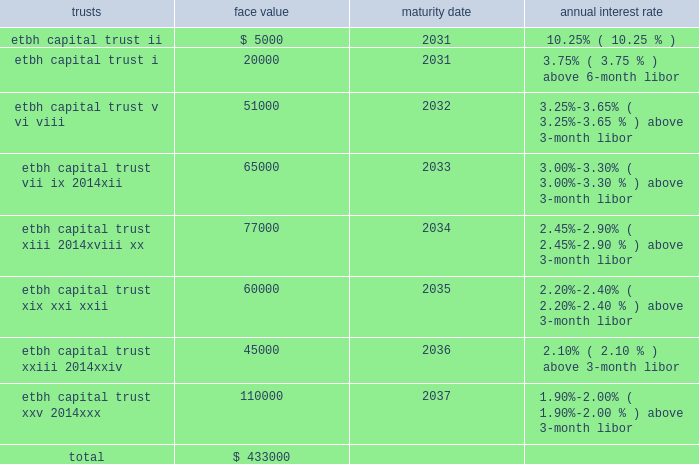Fhlb advances and other borrowings fhlb advances 2014the company had $ 0.7 billion and $ 0.5 billion in floating-rate and $ 0.2 billion and $ 1.8 billion in fixed-rate fhlb advances at december 31 , 2012 and 2011 , respectively .
The floating-rate advances adjust quarterly based on the libor .
During the year ended december 31 , 2012 , $ 650.0 million of fixed-rate fhlb advances were converted to floating-rate for a total cost of approximately $ 128 million which was capitalized and will be amortized over the remaining maturities using the effective interest method .
In addition , during the year ended december 31 , 2012 , the company paid down in advance of maturity $ 1.0 billion of its fhlb advances and recorded $ 69.1 million in losses on the early extinguishment .
This loss was recorded in the gains ( losses ) on early extinguishment of debt line item in the consolidated statement of income ( loss ) .
The company did not have any similar transactions for the years ended december 31 , 2011 and 2010 .
As a condition of its membership in the fhlb atlanta , the company is required to maintain a fhlb stock investment currently equal to the lesser of : a percentage of 0.2% ( 0.2 % ) of total bank assets ; or a dollar cap amount of $ 26 million .
Additionally , the bank must maintain an activity based stock investment which is currently equal to 4.5% ( 4.5 % ) of the bank 2019s outstanding advances at the time of borrowing .
On a quarterly basis , the fhlb atlanta evaluates excess activity based stock holdings for its members and makes a determination regarding quarterly redemption of any excess activity based stock positions .
The company had an investment in fhlb stock of $ 67.4 million and $ 140.2 million at december 31 , 2012 and 2011 , respectively .
The company must also maintain qualified collateral as a percent of its advances , which varies based on the collateral type , and is further adjusted by the outcome of the most recent annual collateral audit and by fhlb 2019s internal ranking of the bank 2019s creditworthiness .
These advances are secured by a pool of mortgage loans and mortgage-backed securities .
At december 31 , 2012 and 2011 , the company pledged loans with a lendable value of $ 4.8 billion and $ 5.0 billion , respectively , of the one- to four-family and home equity loans as collateral in support of both its advances and unused borrowing lines .
Other borrowings 2014prior to 2008 , etbh raised capital through the formation of trusts , which sold trust preferred securities in the capital markets .
The capital securities must be redeemed in whole at the due date , which is generally 30 years after issuance .
Each trust issued floating rate cumulative preferred securities ( 201ctrust preferred securities 201d ) , at par with a liquidation amount of $ 1000 per capital security .
The trusts used the proceeds from the sale of issuances to purchase floating rate junior subordinated debentures ( 201csubordinated debentures 201d ) issued by etbh , which guarantees the trust obligations and contributed proceeds from the sale of its subordinated debentures to e*trade bank in the form of a capital contribution .
The most recent issuance of trust preferred securities occurred in 2007 .
The face values of outstanding trusts at december 31 , 2012 are shown below ( dollars in thousands ) : trusts face value maturity date annual interest rate .
As of december 31 , 2011 , other borrowings also included $ 2.3 million of collateral pledged to the bank by its derivatives counterparties to reduce credit exposure to changes in market value .
The company did not have any similar borrowings for the year ended december 31 , 2012. .
What was the ratio of the company investment in fhlb stock in 2011 to 2012? 
Rationale: the company investment in fhlb stock in 2011 to 2012 of 2.1 to 1
Computations: (140.2 / 67.4)
Answer: 2.08012. 